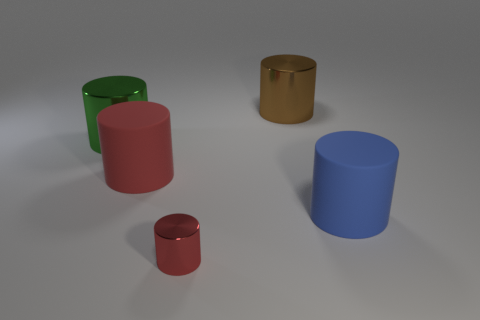If these objects were part of a game, what sort of game could they represent, and how would it be played? Imagining these objects as part of a game, they could represent pieces in a strategy puzzle where each cylinder has a specific value or power. The game could involve arranging the cylinders to create patterns or sequences based on their colors and sizes, with the goal of achieving the highest score or blocking an opponent. 